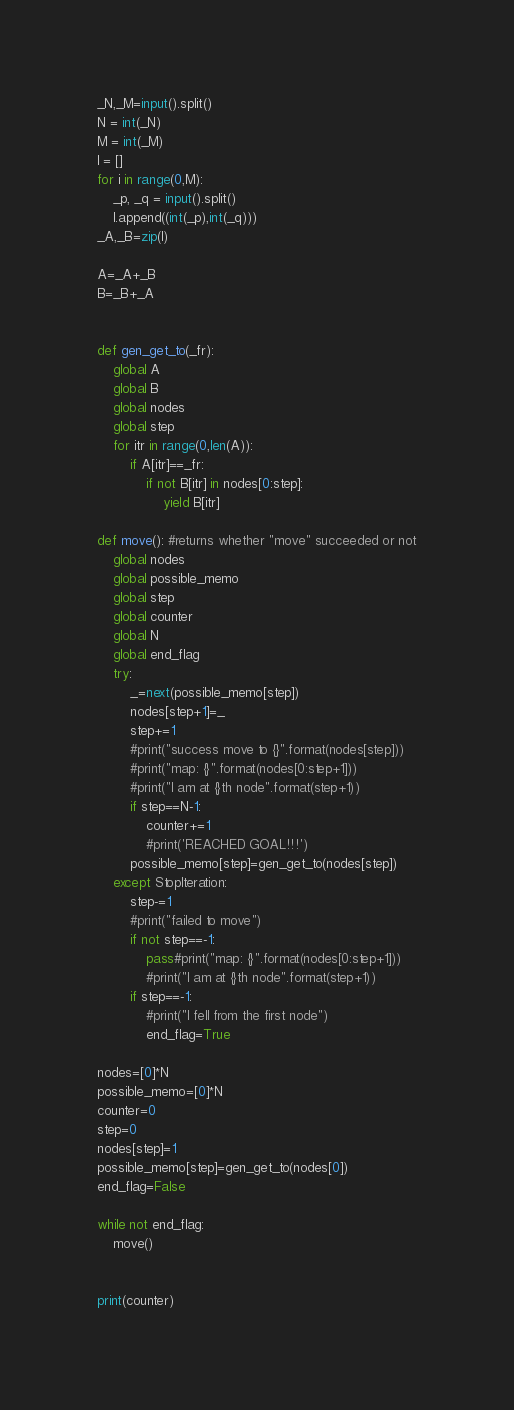<code> <loc_0><loc_0><loc_500><loc_500><_Python_>_N,_M=input().split()
N = int(_N)
M = int(_M)
l = []
for i in range(0,M):
    _p, _q = input().split()
    l.append((int(_p),int(_q)))
_A,_B=zip(l)

A=_A+_B
B=_B+_A


def gen_get_to(_fr):
    global A
    global B
    global nodes
    global step
    for itr in range(0,len(A)):
        if A[itr]==_fr:
            if not B[itr] in nodes[0:step]:
                yield B[itr]

def move(): #returns whether "move" succeeded or not
    global nodes
    global possible_memo
    global step
    global counter
    global N
    global end_flag
    try:
        _=next(possible_memo[step])
        nodes[step+1]=_
        step+=1
        #print("success move to {}".format(nodes[step]))
        #print("map: {}".format(nodes[0:step+1]))
        #print("I am at {}th node".format(step+1))
        if step==N-1:
            counter+=1
            #print('REACHED GOAL!!!')
        possible_memo[step]=gen_get_to(nodes[step])
    except StopIteration:
        step-=1
        #print("failed to move")
        if not step==-1:
            pass#print("map: {}".format(nodes[0:step+1]))
            #print("I am at {}th node".format(step+1))
        if step==-1:
            #print("I fell from the first node")
            end_flag=True

nodes=[0]*N
possible_memo=[0]*N
counter=0
step=0
nodes[step]=1
possible_memo[step]=gen_get_to(nodes[0])
end_flag=False

while not end_flag:
    move()


print(counter)</code> 